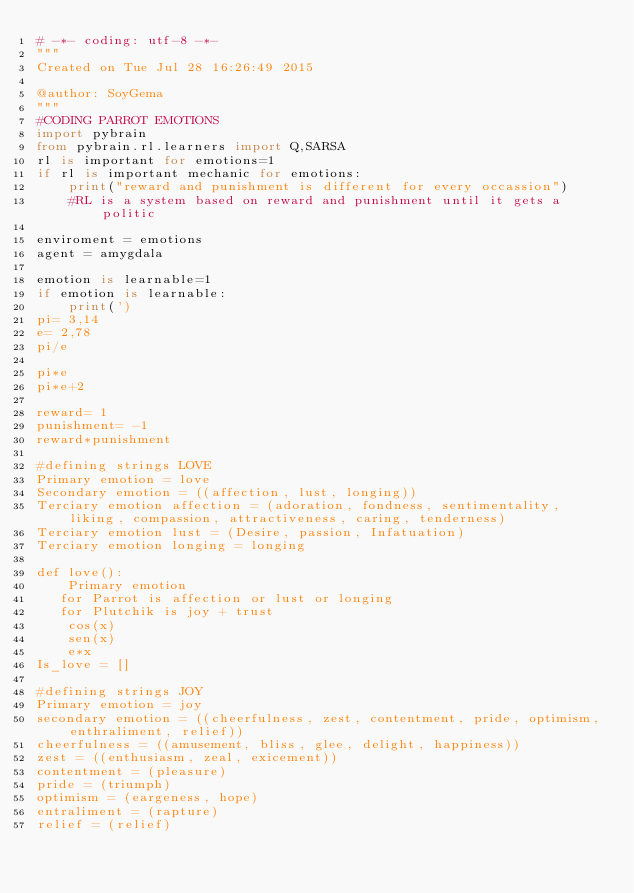<code> <loc_0><loc_0><loc_500><loc_500><_Python_># -*- coding: utf-8 -*-
"""
Created on Tue Jul 28 16:26:49 2015

@author: SoyGema
"""
#CODING PARROT EMOTIONS 
import pybrain
from pybrain.rl.learners import Q,SARSA
rl is important for emotions=1
if rl is important mechanic for emotions:
    print("reward and punishment is different for every occassion")
    #RL is a system based on reward and punishment until it gets a politic
    
enviroment = emotions
agent = amygdala

emotion is learnable=1
if emotion is learnable:
    print(')
pi= 3,14
e= 2,78
pi/e

pi*e
pi*e+2

reward= 1
punishment= -1
reward*punishment

#defining strings LOVE
Primary emotion = love 
Secondary emotion = ((affection, lust, longing))
Terciary emotion affection = (adoration, fondness, sentimentality, liking, compassion, attractiveness, caring, tenderness)
Terciary emotion lust = (Desire, passion, Infatuation)
Terciary emotion longing = longing

def love():
    Primary emotion
   for Parrot is affection or lust or longing
   for Plutchik is joy + trust
    cos(x)
    sen(x)
    e*x
Is_love = []

#defining strings JOY
Primary emotion = joy
secondary emotion = ((cheerfulness, zest, contentment, pride, optimism, enthraliment, relief))
cheerfulness = ((amusement, bliss, glee, delight, happiness))
zest = ((enthusiasm, zeal, exicement))
contentment = (pleasure)
pride = (triumph)
optimism = (eargeness, hope)
entraliment = (rapture)
relief = (relief)
</code> 